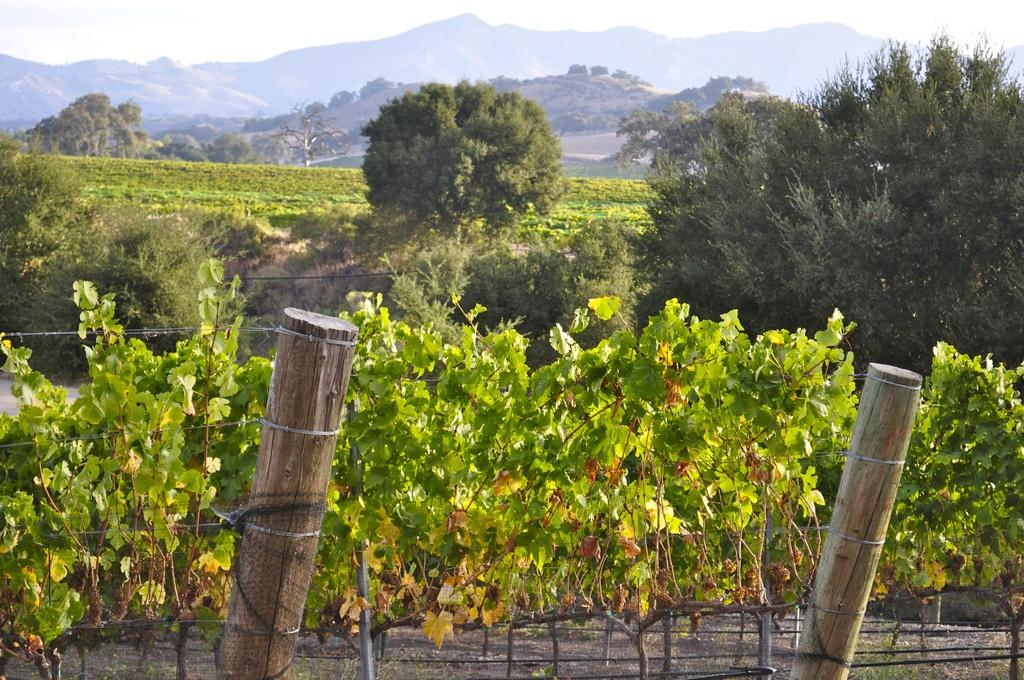What is located at the bottom of the image? There is a fence, wooden poles, and plants at the bottom of the image. What can be seen in the background of the image? There are trees, plants, mountains, and the sky visible in the background of the image. Reasoning: Let's think step by identifying the main subjects and objects in the image based on the provided facts. We then formulate questions that focus on the location and characteristics of these subjects and objects, ensuring that each question can be answered definitively with the information given. We avoid yes/no questions and ensure that the language is simple and clear. Absurd Question/Answer: Is there a beggar asking for money in the image? There is no beggar present in the image. What type of trick can be seen being performed in the image? There is no trick being performed in the image. What type of body is visible in the image? There is no body present in the image. What type of body of water can be seen in the image? There is no body of water present in the image. 